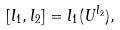<formula> <loc_0><loc_0><loc_500><loc_500>[ l _ { 1 } , l _ { 2 } ] = l _ { 1 } ( U ^ { l _ { 2 } } ) ,</formula> 